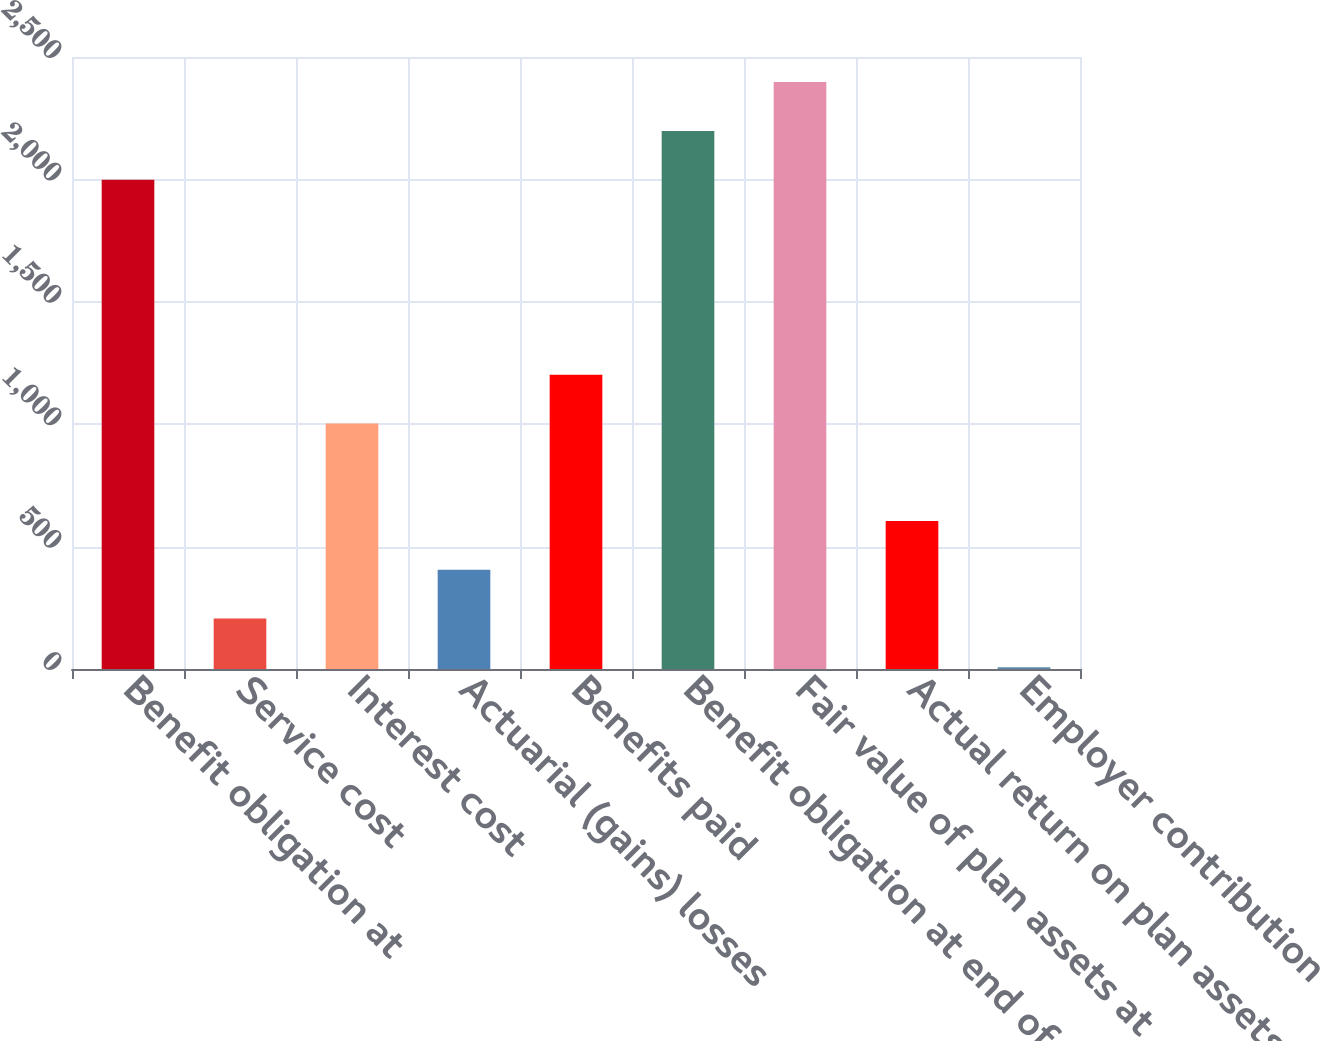Convert chart to OTSL. <chart><loc_0><loc_0><loc_500><loc_500><bar_chart><fcel>Benefit obligation at<fcel>Service cost<fcel>Interest cost<fcel>Actuarial (gains) losses<fcel>Benefits paid<fcel>Benefit obligation at end of<fcel>Fair value of plan assets at<fcel>Actual return on plan assets<fcel>Employer contribution<nl><fcel>1999<fcel>206.2<fcel>1003<fcel>405.4<fcel>1202.2<fcel>2198.2<fcel>2397.4<fcel>604.6<fcel>7<nl></chart> 